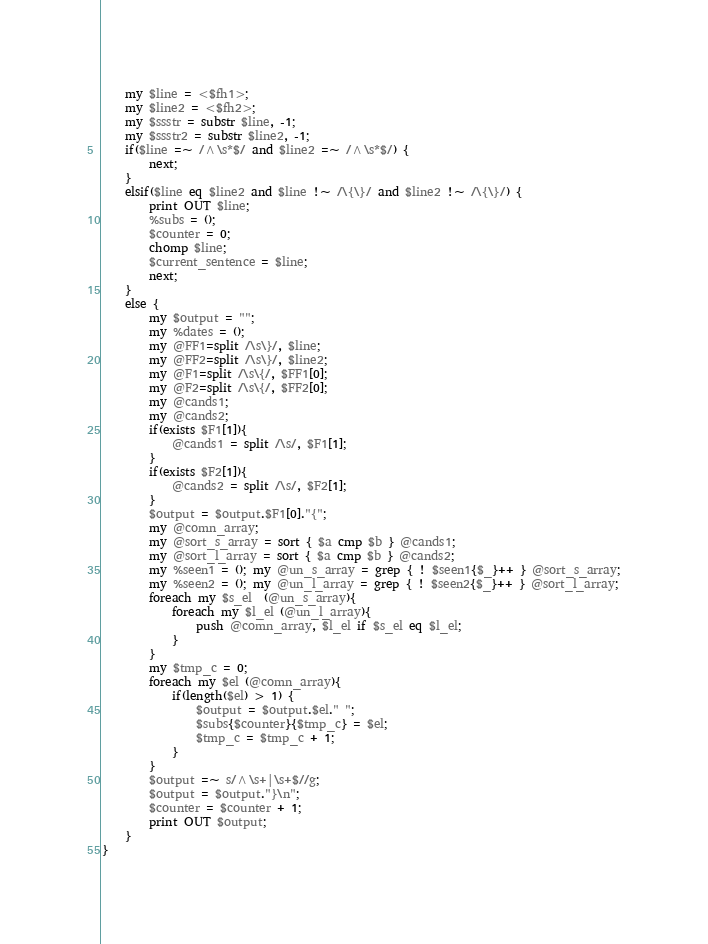Convert code to text. <code><loc_0><loc_0><loc_500><loc_500><_Perl_>    my $line = <$fh1>;
    my $line2 = <$fh2>;
    my $ssstr = substr $line, -1;
    my $ssstr2 = substr $line2, -1;
    if($line =~ /^\s*$/ and $line2 =~ /^\s*$/) {
        next;
    }
    elsif($line eq $line2 and $line !~ /\{\}/ and $line2 !~ /\{\}/) {
        print OUT $line;
        %subs = ();
        $counter = 0;
        chomp $line;
        $current_sentence = $line;
        next;
    }
    else {
        my $output = "";
        my %dates = ();
        my @FF1=split /\s\}/, $line;
        my @FF2=split /\s\}/, $line2;
        my @F1=split /\s\{/, $FF1[0];
        my @F2=split /\s\{/, $FF2[0];
        my @cands1;
        my @cands2;
        if(exists $F1[1]){
            @cands1 = split /\s/, $F1[1];
        }
        if(exists $F2[1]){
            @cands2 = split /\s/, $F2[1];
        }
        $output = $output.$F1[0]."{";
        my @comn_array;
        my @sort_s_array = sort { $a cmp $b } @cands1;
        my @sort_l_array = sort { $a cmp $b } @cands2;
        my %seen1 = (); my @un_s_array = grep { ! $seen1{$_}++ } @sort_s_array;
        my %seen2 = (); my @un_l_array = grep { ! $seen2{$_}++ } @sort_l_array;
        foreach my $s_el  (@un_s_array){
            foreach my $l_el (@un_l_array){
                push @comn_array, $l_el if $s_el eq $l_el;
            }
        }
        my $tmp_c = 0;
        foreach my $el (@comn_array){
            if(length($el) > 1) {
                $output = $output.$el." ";
                $subs{$counter}{$tmp_c} = $el;
                $tmp_c = $tmp_c + 1;
            }
        }
        $output =~ s/^\s+|\s+$//g;
        $output = $output."}\n";
        $counter = $counter + 1;
        print OUT $output;
    }
}
</code> 